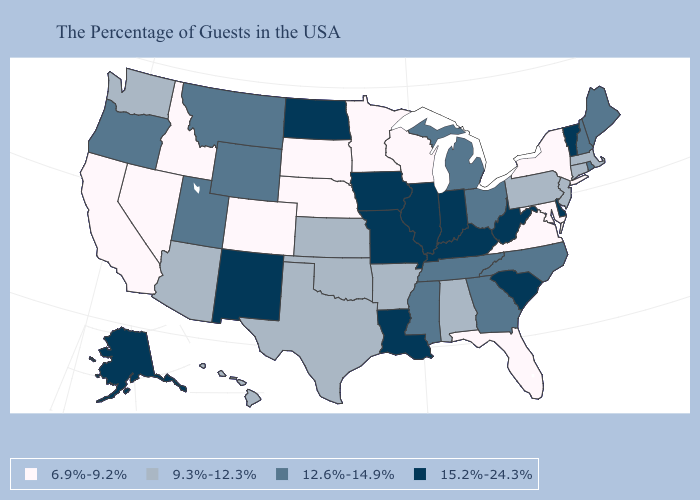Name the states that have a value in the range 6.9%-9.2%?
Short answer required. New York, Maryland, Virginia, Florida, Wisconsin, Minnesota, Nebraska, South Dakota, Colorado, Idaho, Nevada, California. What is the lowest value in the Northeast?
Concise answer only. 6.9%-9.2%. Among the states that border Colorado , does New Mexico have the highest value?
Quick response, please. Yes. Name the states that have a value in the range 15.2%-24.3%?
Give a very brief answer. Vermont, Delaware, South Carolina, West Virginia, Kentucky, Indiana, Illinois, Louisiana, Missouri, Iowa, North Dakota, New Mexico, Alaska. Among the states that border Georgia , does North Carolina have the lowest value?
Keep it brief. No. What is the value of Vermont?
Quick response, please. 15.2%-24.3%. What is the value of Georgia?
Short answer required. 12.6%-14.9%. What is the highest value in states that border Maine?
Concise answer only. 12.6%-14.9%. Which states have the highest value in the USA?
Be succinct. Vermont, Delaware, South Carolina, West Virginia, Kentucky, Indiana, Illinois, Louisiana, Missouri, Iowa, North Dakota, New Mexico, Alaska. Does the map have missing data?
Concise answer only. No. What is the value of Missouri?
Give a very brief answer. 15.2%-24.3%. Among the states that border Florida , which have the lowest value?
Answer briefly. Alabama. Name the states that have a value in the range 12.6%-14.9%?
Answer briefly. Maine, Rhode Island, New Hampshire, North Carolina, Ohio, Georgia, Michigan, Tennessee, Mississippi, Wyoming, Utah, Montana, Oregon. Name the states that have a value in the range 15.2%-24.3%?
Write a very short answer. Vermont, Delaware, South Carolina, West Virginia, Kentucky, Indiana, Illinois, Louisiana, Missouri, Iowa, North Dakota, New Mexico, Alaska. What is the value of Tennessee?
Be succinct. 12.6%-14.9%. 